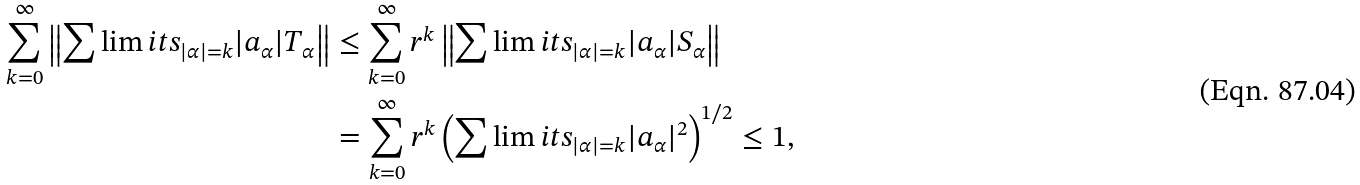<formula> <loc_0><loc_0><loc_500><loc_500>\sum _ { k = 0 } ^ { \infty } \left \| \sum \lim i t s _ { | \alpha | = k } | a _ { \alpha } | T _ { \alpha } \right \| & \leq \sum _ { k = 0 } ^ { \infty } r ^ { k } \left \| \sum \lim i t s _ { | \alpha | = k } | a _ { \alpha } | S _ { \alpha } \right \| \\ & = \sum _ { k = 0 } ^ { \infty } r ^ { k } \left ( \sum \lim i t s _ { | \alpha | = k } | a _ { \alpha } | ^ { 2 } \right ) ^ { 1 / 2 } \leq 1 ,</formula> 